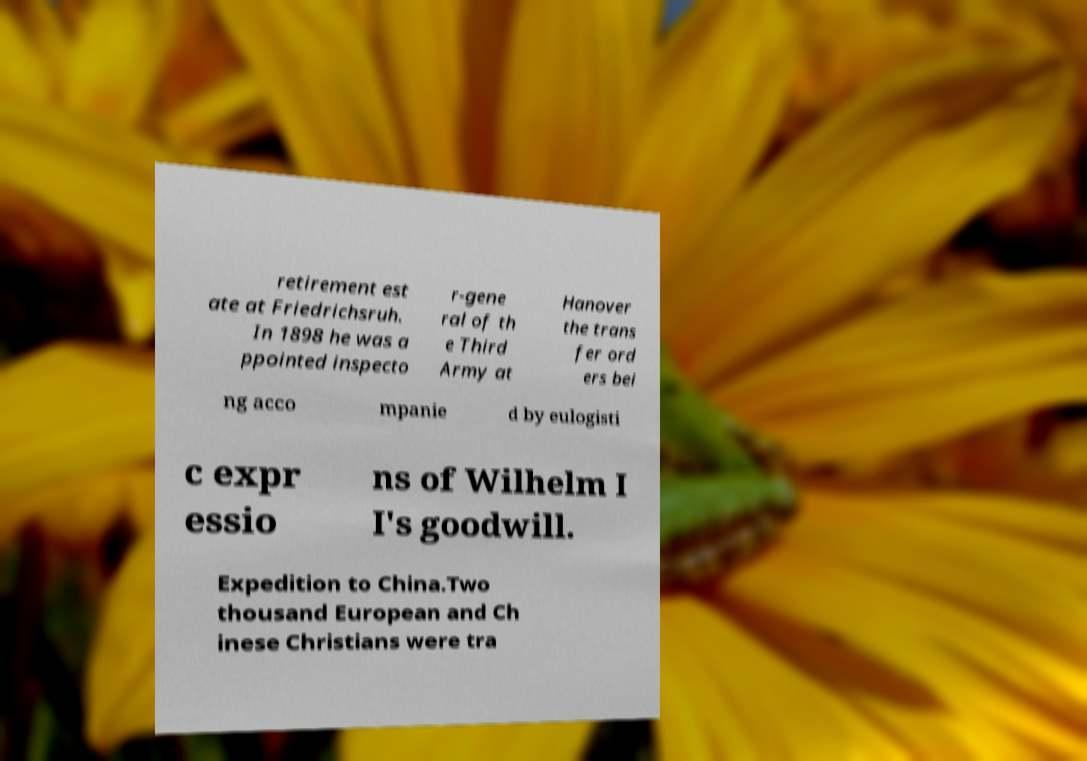For documentation purposes, I need the text within this image transcribed. Could you provide that? retirement est ate at Friedrichsruh. In 1898 he was a ppointed inspecto r-gene ral of th e Third Army at Hanover the trans fer ord ers bei ng acco mpanie d by eulogisti c expr essio ns of Wilhelm I I's goodwill. Expedition to China.Two thousand European and Ch inese Christians were tra 